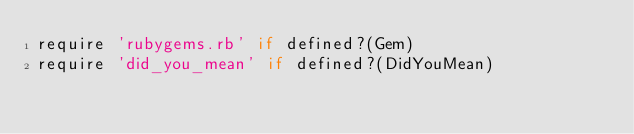<code> <loc_0><loc_0><loc_500><loc_500><_Ruby_>require 'rubygems.rb' if defined?(Gem)
require 'did_you_mean' if defined?(DidYouMean)
</code> 